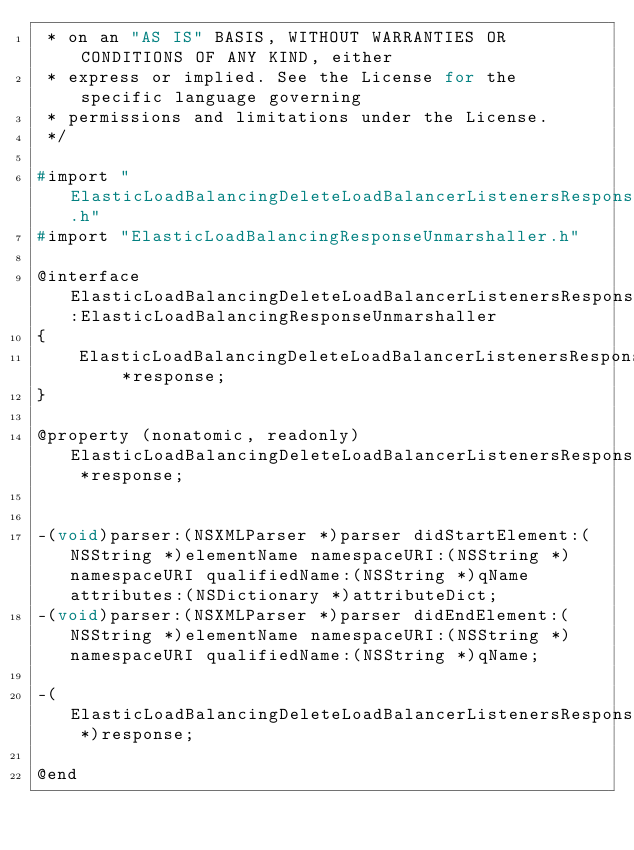Convert code to text. <code><loc_0><loc_0><loc_500><loc_500><_C_> * on an "AS IS" BASIS, WITHOUT WARRANTIES OR CONDITIONS OF ANY KIND, either
 * express or implied. See the License for the specific language governing
 * permissions and limitations under the License.
 */

#import "ElasticLoadBalancingDeleteLoadBalancerListenersResponse.h"
#import "ElasticLoadBalancingResponseUnmarshaller.h"

@interface ElasticLoadBalancingDeleteLoadBalancerListenersResponseUnmarshaller:ElasticLoadBalancingResponseUnmarshaller
{
    ElasticLoadBalancingDeleteLoadBalancerListenersResponse *response;
}

@property (nonatomic, readonly) ElasticLoadBalancingDeleteLoadBalancerListenersResponse *response;


-(void)parser:(NSXMLParser *)parser didStartElement:(NSString *)elementName namespaceURI:(NSString *)namespaceURI qualifiedName:(NSString *)qName attributes:(NSDictionary *)attributeDict;
-(void)parser:(NSXMLParser *)parser didEndElement:(NSString *)elementName namespaceURI:(NSString *)namespaceURI qualifiedName:(NSString *)qName;

-(ElasticLoadBalancingDeleteLoadBalancerListenersResponse *)response;

@end
</code> 